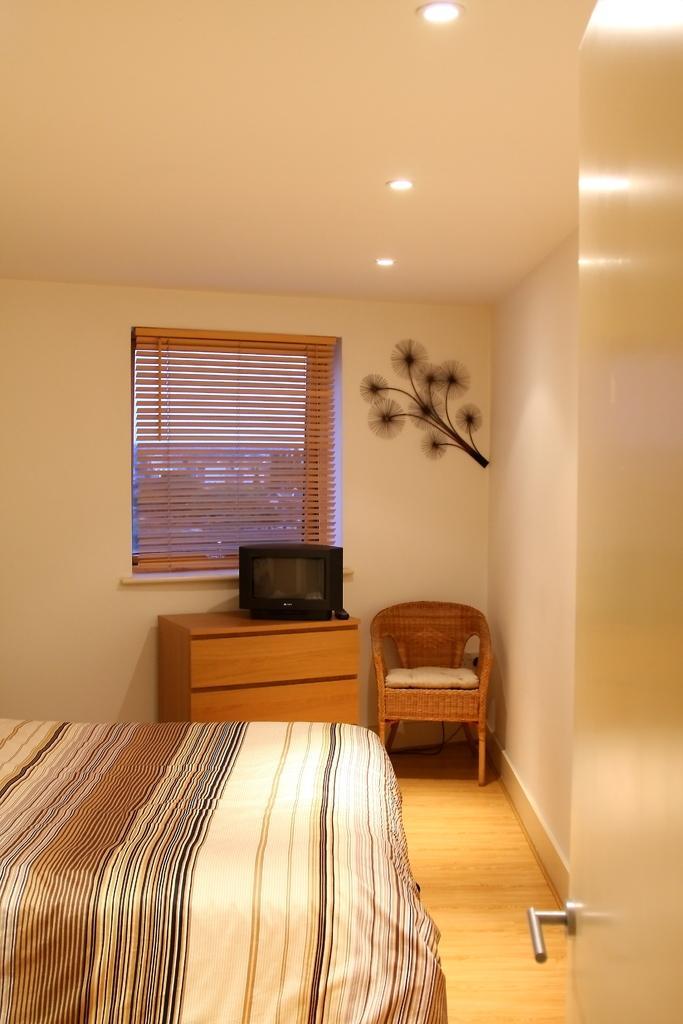Can you describe this image briefly? In this picture we can see a room with bed, chair, cupboard and on cupboard we have television, window with curtains and here it is a door. 